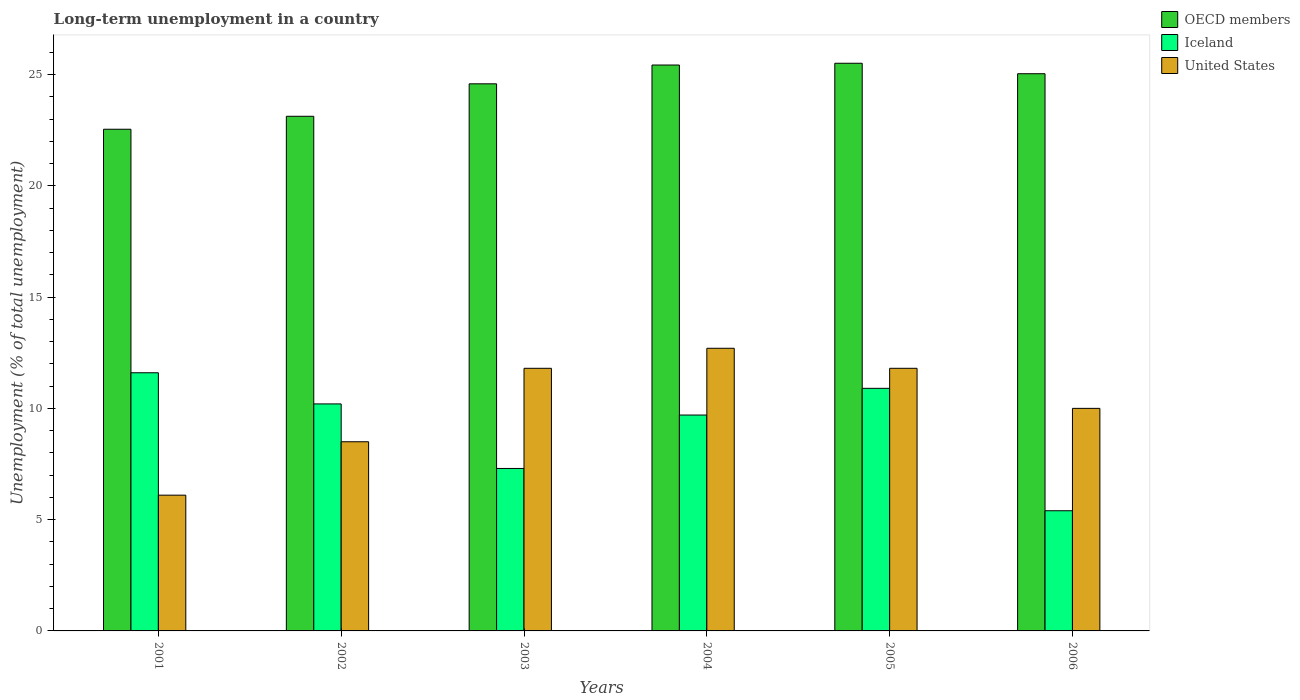Are the number of bars per tick equal to the number of legend labels?
Provide a short and direct response. Yes. Are the number of bars on each tick of the X-axis equal?
Your answer should be very brief. Yes. How many bars are there on the 6th tick from the left?
Keep it short and to the point. 3. What is the percentage of long-term unemployed population in OECD members in 2004?
Ensure brevity in your answer.  25.43. Across all years, what is the maximum percentage of long-term unemployed population in OECD members?
Your response must be concise. 25.51. Across all years, what is the minimum percentage of long-term unemployed population in OECD members?
Your answer should be very brief. 22.54. In which year was the percentage of long-term unemployed population in OECD members maximum?
Give a very brief answer. 2005. In which year was the percentage of long-term unemployed population in Iceland minimum?
Your answer should be compact. 2006. What is the total percentage of long-term unemployed population in Iceland in the graph?
Your answer should be very brief. 55.1. What is the difference between the percentage of long-term unemployed population in Iceland in 2003 and that in 2006?
Your answer should be compact. 1.9. What is the difference between the percentage of long-term unemployed population in Iceland in 2003 and the percentage of long-term unemployed population in United States in 2001?
Offer a very short reply. 1.2. What is the average percentage of long-term unemployed population in United States per year?
Offer a terse response. 10.15. In the year 2005, what is the difference between the percentage of long-term unemployed population in Iceland and percentage of long-term unemployed population in United States?
Provide a short and direct response. -0.9. In how many years, is the percentage of long-term unemployed population in OECD members greater than 6 %?
Your answer should be very brief. 6. What is the ratio of the percentage of long-term unemployed population in Iceland in 2001 to that in 2002?
Provide a short and direct response. 1.14. Is the percentage of long-term unemployed population in OECD members in 2002 less than that in 2003?
Give a very brief answer. Yes. Is the difference between the percentage of long-term unemployed population in Iceland in 2003 and 2004 greater than the difference between the percentage of long-term unemployed population in United States in 2003 and 2004?
Your answer should be very brief. No. What is the difference between the highest and the second highest percentage of long-term unemployed population in United States?
Your response must be concise. 0.9. What is the difference between the highest and the lowest percentage of long-term unemployed population in Iceland?
Your answer should be compact. 6.2. Is it the case that in every year, the sum of the percentage of long-term unemployed population in Iceland and percentage of long-term unemployed population in United States is greater than the percentage of long-term unemployed population in OECD members?
Offer a very short reply. No. How many bars are there?
Offer a very short reply. 18. Are all the bars in the graph horizontal?
Ensure brevity in your answer.  No. Are the values on the major ticks of Y-axis written in scientific E-notation?
Ensure brevity in your answer.  No. How many legend labels are there?
Provide a succinct answer. 3. How are the legend labels stacked?
Give a very brief answer. Vertical. What is the title of the graph?
Provide a short and direct response. Long-term unemployment in a country. What is the label or title of the Y-axis?
Keep it short and to the point. Unemployment (% of total unemployment). What is the Unemployment (% of total unemployment) of OECD members in 2001?
Your answer should be very brief. 22.54. What is the Unemployment (% of total unemployment) in Iceland in 2001?
Give a very brief answer. 11.6. What is the Unemployment (% of total unemployment) in United States in 2001?
Give a very brief answer. 6.1. What is the Unemployment (% of total unemployment) of OECD members in 2002?
Ensure brevity in your answer.  23.12. What is the Unemployment (% of total unemployment) of Iceland in 2002?
Your answer should be very brief. 10.2. What is the Unemployment (% of total unemployment) in OECD members in 2003?
Provide a short and direct response. 24.58. What is the Unemployment (% of total unemployment) in Iceland in 2003?
Provide a short and direct response. 7.3. What is the Unemployment (% of total unemployment) in United States in 2003?
Your response must be concise. 11.8. What is the Unemployment (% of total unemployment) of OECD members in 2004?
Make the answer very short. 25.43. What is the Unemployment (% of total unemployment) in Iceland in 2004?
Ensure brevity in your answer.  9.7. What is the Unemployment (% of total unemployment) in United States in 2004?
Provide a short and direct response. 12.7. What is the Unemployment (% of total unemployment) in OECD members in 2005?
Ensure brevity in your answer.  25.51. What is the Unemployment (% of total unemployment) in Iceland in 2005?
Your response must be concise. 10.9. What is the Unemployment (% of total unemployment) of United States in 2005?
Provide a short and direct response. 11.8. What is the Unemployment (% of total unemployment) in OECD members in 2006?
Your answer should be very brief. 25.04. What is the Unemployment (% of total unemployment) in Iceland in 2006?
Your answer should be compact. 5.4. What is the Unemployment (% of total unemployment) of United States in 2006?
Your answer should be compact. 10. Across all years, what is the maximum Unemployment (% of total unemployment) of OECD members?
Give a very brief answer. 25.51. Across all years, what is the maximum Unemployment (% of total unemployment) in Iceland?
Keep it short and to the point. 11.6. Across all years, what is the maximum Unemployment (% of total unemployment) of United States?
Make the answer very short. 12.7. Across all years, what is the minimum Unemployment (% of total unemployment) in OECD members?
Make the answer very short. 22.54. Across all years, what is the minimum Unemployment (% of total unemployment) in Iceland?
Offer a terse response. 5.4. Across all years, what is the minimum Unemployment (% of total unemployment) of United States?
Ensure brevity in your answer.  6.1. What is the total Unemployment (% of total unemployment) of OECD members in the graph?
Your answer should be very brief. 146.22. What is the total Unemployment (% of total unemployment) of Iceland in the graph?
Your answer should be compact. 55.1. What is the total Unemployment (% of total unemployment) in United States in the graph?
Your response must be concise. 60.9. What is the difference between the Unemployment (% of total unemployment) in OECD members in 2001 and that in 2002?
Keep it short and to the point. -0.58. What is the difference between the Unemployment (% of total unemployment) in United States in 2001 and that in 2002?
Give a very brief answer. -2.4. What is the difference between the Unemployment (% of total unemployment) in OECD members in 2001 and that in 2003?
Provide a succinct answer. -2.04. What is the difference between the Unemployment (% of total unemployment) of Iceland in 2001 and that in 2003?
Keep it short and to the point. 4.3. What is the difference between the Unemployment (% of total unemployment) in United States in 2001 and that in 2003?
Give a very brief answer. -5.7. What is the difference between the Unemployment (% of total unemployment) in OECD members in 2001 and that in 2004?
Your response must be concise. -2.89. What is the difference between the Unemployment (% of total unemployment) in United States in 2001 and that in 2004?
Ensure brevity in your answer.  -6.6. What is the difference between the Unemployment (% of total unemployment) in OECD members in 2001 and that in 2005?
Your answer should be very brief. -2.96. What is the difference between the Unemployment (% of total unemployment) in Iceland in 2001 and that in 2005?
Ensure brevity in your answer.  0.7. What is the difference between the Unemployment (% of total unemployment) of United States in 2001 and that in 2005?
Make the answer very short. -5.7. What is the difference between the Unemployment (% of total unemployment) of OECD members in 2001 and that in 2006?
Your answer should be compact. -2.49. What is the difference between the Unemployment (% of total unemployment) in Iceland in 2001 and that in 2006?
Provide a succinct answer. 6.2. What is the difference between the Unemployment (% of total unemployment) in United States in 2001 and that in 2006?
Provide a short and direct response. -3.9. What is the difference between the Unemployment (% of total unemployment) of OECD members in 2002 and that in 2003?
Provide a succinct answer. -1.46. What is the difference between the Unemployment (% of total unemployment) in Iceland in 2002 and that in 2003?
Ensure brevity in your answer.  2.9. What is the difference between the Unemployment (% of total unemployment) of OECD members in 2002 and that in 2004?
Offer a terse response. -2.3. What is the difference between the Unemployment (% of total unemployment) of OECD members in 2002 and that in 2005?
Keep it short and to the point. -2.38. What is the difference between the Unemployment (% of total unemployment) in OECD members in 2002 and that in 2006?
Offer a very short reply. -1.91. What is the difference between the Unemployment (% of total unemployment) in OECD members in 2003 and that in 2004?
Give a very brief answer. -0.84. What is the difference between the Unemployment (% of total unemployment) in Iceland in 2003 and that in 2004?
Your response must be concise. -2.4. What is the difference between the Unemployment (% of total unemployment) in United States in 2003 and that in 2004?
Provide a short and direct response. -0.9. What is the difference between the Unemployment (% of total unemployment) of OECD members in 2003 and that in 2005?
Give a very brief answer. -0.92. What is the difference between the Unemployment (% of total unemployment) in OECD members in 2003 and that in 2006?
Provide a short and direct response. -0.45. What is the difference between the Unemployment (% of total unemployment) of Iceland in 2003 and that in 2006?
Provide a succinct answer. 1.9. What is the difference between the Unemployment (% of total unemployment) of United States in 2003 and that in 2006?
Give a very brief answer. 1.8. What is the difference between the Unemployment (% of total unemployment) of OECD members in 2004 and that in 2005?
Provide a succinct answer. -0.08. What is the difference between the Unemployment (% of total unemployment) in United States in 2004 and that in 2005?
Offer a terse response. 0.9. What is the difference between the Unemployment (% of total unemployment) of OECD members in 2004 and that in 2006?
Provide a succinct answer. 0.39. What is the difference between the Unemployment (% of total unemployment) in OECD members in 2005 and that in 2006?
Ensure brevity in your answer.  0.47. What is the difference between the Unemployment (% of total unemployment) in OECD members in 2001 and the Unemployment (% of total unemployment) in Iceland in 2002?
Offer a terse response. 12.34. What is the difference between the Unemployment (% of total unemployment) in OECD members in 2001 and the Unemployment (% of total unemployment) in United States in 2002?
Your answer should be very brief. 14.04. What is the difference between the Unemployment (% of total unemployment) of Iceland in 2001 and the Unemployment (% of total unemployment) of United States in 2002?
Offer a terse response. 3.1. What is the difference between the Unemployment (% of total unemployment) of OECD members in 2001 and the Unemployment (% of total unemployment) of Iceland in 2003?
Your answer should be compact. 15.24. What is the difference between the Unemployment (% of total unemployment) of OECD members in 2001 and the Unemployment (% of total unemployment) of United States in 2003?
Your answer should be very brief. 10.74. What is the difference between the Unemployment (% of total unemployment) of Iceland in 2001 and the Unemployment (% of total unemployment) of United States in 2003?
Make the answer very short. -0.2. What is the difference between the Unemployment (% of total unemployment) of OECD members in 2001 and the Unemployment (% of total unemployment) of Iceland in 2004?
Give a very brief answer. 12.84. What is the difference between the Unemployment (% of total unemployment) in OECD members in 2001 and the Unemployment (% of total unemployment) in United States in 2004?
Provide a succinct answer. 9.84. What is the difference between the Unemployment (% of total unemployment) of Iceland in 2001 and the Unemployment (% of total unemployment) of United States in 2004?
Give a very brief answer. -1.1. What is the difference between the Unemployment (% of total unemployment) in OECD members in 2001 and the Unemployment (% of total unemployment) in Iceland in 2005?
Your response must be concise. 11.64. What is the difference between the Unemployment (% of total unemployment) of OECD members in 2001 and the Unemployment (% of total unemployment) of United States in 2005?
Give a very brief answer. 10.74. What is the difference between the Unemployment (% of total unemployment) in OECD members in 2001 and the Unemployment (% of total unemployment) in Iceland in 2006?
Your answer should be very brief. 17.14. What is the difference between the Unemployment (% of total unemployment) of OECD members in 2001 and the Unemployment (% of total unemployment) of United States in 2006?
Your answer should be very brief. 12.54. What is the difference between the Unemployment (% of total unemployment) in OECD members in 2002 and the Unemployment (% of total unemployment) in Iceland in 2003?
Make the answer very short. 15.82. What is the difference between the Unemployment (% of total unemployment) of OECD members in 2002 and the Unemployment (% of total unemployment) of United States in 2003?
Ensure brevity in your answer.  11.32. What is the difference between the Unemployment (% of total unemployment) of OECD members in 2002 and the Unemployment (% of total unemployment) of Iceland in 2004?
Provide a short and direct response. 13.42. What is the difference between the Unemployment (% of total unemployment) in OECD members in 2002 and the Unemployment (% of total unemployment) in United States in 2004?
Make the answer very short. 10.42. What is the difference between the Unemployment (% of total unemployment) in OECD members in 2002 and the Unemployment (% of total unemployment) in Iceland in 2005?
Offer a very short reply. 12.22. What is the difference between the Unemployment (% of total unemployment) in OECD members in 2002 and the Unemployment (% of total unemployment) in United States in 2005?
Provide a succinct answer. 11.32. What is the difference between the Unemployment (% of total unemployment) of Iceland in 2002 and the Unemployment (% of total unemployment) of United States in 2005?
Provide a succinct answer. -1.6. What is the difference between the Unemployment (% of total unemployment) in OECD members in 2002 and the Unemployment (% of total unemployment) in Iceland in 2006?
Your answer should be very brief. 17.72. What is the difference between the Unemployment (% of total unemployment) in OECD members in 2002 and the Unemployment (% of total unemployment) in United States in 2006?
Your response must be concise. 13.12. What is the difference between the Unemployment (% of total unemployment) of OECD members in 2003 and the Unemployment (% of total unemployment) of Iceland in 2004?
Provide a succinct answer. 14.88. What is the difference between the Unemployment (% of total unemployment) in OECD members in 2003 and the Unemployment (% of total unemployment) in United States in 2004?
Make the answer very short. 11.88. What is the difference between the Unemployment (% of total unemployment) of Iceland in 2003 and the Unemployment (% of total unemployment) of United States in 2004?
Provide a succinct answer. -5.4. What is the difference between the Unemployment (% of total unemployment) in OECD members in 2003 and the Unemployment (% of total unemployment) in Iceland in 2005?
Offer a very short reply. 13.68. What is the difference between the Unemployment (% of total unemployment) of OECD members in 2003 and the Unemployment (% of total unemployment) of United States in 2005?
Your answer should be compact. 12.78. What is the difference between the Unemployment (% of total unemployment) of Iceland in 2003 and the Unemployment (% of total unemployment) of United States in 2005?
Give a very brief answer. -4.5. What is the difference between the Unemployment (% of total unemployment) in OECD members in 2003 and the Unemployment (% of total unemployment) in Iceland in 2006?
Keep it short and to the point. 19.18. What is the difference between the Unemployment (% of total unemployment) in OECD members in 2003 and the Unemployment (% of total unemployment) in United States in 2006?
Provide a short and direct response. 14.58. What is the difference between the Unemployment (% of total unemployment) of Iceland in 2003 and the Unemployment (% of total unemployment) of United States in 2006?
Give a very brief answer. -2.7. What is the difference between the Unemployment (% of total unemployment) in OECD members in 2004 and the Unemployment (% of total unemployment) in Iceland in 2005?
Give a very brief answer. 14.53. What is the difference between the Unemployment (% of total unemployment) in OECD members in 2004 and the Unemployment (% of total unemployment) in United States in 2005?
Your answer should be very brief. 13.63. What is the difference between the Unemployment (% of total unemployment) in Iceland in 2004 and the Unemployment (% of total unemployment) in United States in 2005?
Your answer should be compact. -2.1. What is the difference between the Unemployment (% of total unemployment) of OECD members in 2004 and the Unemployment (% of total unemployment) of Iceland in 2006?
Your answer should be very brief. 20.03. What is the difference between the Unemployment (% of total unemployment) in OECD members in 2004 and the Unemployment (% of total unemployment) in United States in 2006?
Provide a short and direct response. 15.43. What is the difference between the Unemployment (% of total unemployment) in OECD members in 2005 and the Unemployment (% of total unemployment) in Iceland in 2006?
Offer a terse response. 20.11. What is the difference between the Unemployment (% of total unemployment) of OECD members in 2005 and the Unemployment (% of total unemployment) of United States in 2006?
Keep it short and to the point. 15.51. What is the difference between the Unemployment (% of total unemployment) in Iceland in 2005 and the Unemployment (% of total unemployment) in United States in 2006?
Make the answer very short. 0.9. What is the average Unemployment (% of total unemployment) in OECD members per year?
Keep it short and to the point. 24.37. What is the average Unemployment (% of total unemployment) in Iceland per year?
Your answer should be very brief. 9.18. What is the average Unemployment (% of total unemployment) in United States per year?
Provide a succinct answer. 10.15. In the year 2001, what is the difference between the Unemployment (% of total unemployment) of OECD members and Unemployment (% of total unemployment) of Iceland?
Provide a succinct answer. 10.94. In the year 2001, what is the difference between the Unemployment (% of total unemployment) in OECD members and Unemployment (% of total unemployment) in United States?
Provide a short and direct response. 16.44. In the year 2001, what is the difference between the Unemployment (% of total unemployment) of Iceland and Unemployment (% of total unemployment) of United States?
Offer a very short reply. 5.5. In the year 2002, what is the difference between the Unemployment (% of total unemployment) in OECD members and Unemployment (% of total unemployment) in Iceland?
Provide a succinct answer. 12.92. In the year 2002, what is the difference between the Unemployment (% of total unemployment) of OECD members and Unemployment (% of total unemployment) of United States?
Give a very brief answer. 14.62. In the year 2003, what is the difference between the Unemployment (% of total unemployment) in OECD members and Unemployment (% of total unemployment) in Iceland?
Provide a short and direct response. 17.28. In the year 2003, what is the difference between the Unemployment (% of total unemployment) in OECD members and Unemployment (% of total unemployment) in United States?
Keep it short and to the point. 12.78. In the year 2004, what is the difference between the Unemployment (% of total unemployment) in OECD members and Unemployment (% of total unemployment) in Iceland?
Offer a very short reply. 15.73. In the year 2004, what is the difference between the Unemployment (% of total unemployment) of OECD members and Unemployment (% of total unemployment) of United States?
Provide a short and direct response. 12.73. In the year 2004, what is the difference between the Unemployment (% of total unemployment) of Iceland and Unemployment (% of total unemployment) of United States?
Make the answer very short. -3. In the year 2005, what is the difference between the Unemployment (% of total unemployment) of OECD members and Unemployment (% of total unemployment) of Iceland?
Keep it short and to the point. 14.61. In the year 2005, what is the difference between the Unemployment (% of total unemployment) in OECD members and Unemployment (% of total unemployment) in United States?
Your answer should be very brief. 13.71. In the year 2005, what is the difference between the Unemployment (% of total unemployment) of Iceland and Unemployment (% of total unemployment) of United States?
Offer a terse response. -0.9. In the year 2006, what is the difference between the Unemployment (% of total unemployment) in OECD members and Unemployment (% of total unemployment) in Iceland?
Your answer should be very brief. 19.64. In the year 2006, what is the difference between the Unemployment (% of total unemployment) of OECD members and Unemployment (% of total unemployment) of United States?
Offer a terse response. 15.04. What is the ratio of the Unemployment (% of total unemployment) in OECD members in 2001 to that in 2002?
Your answer should be very brief. 0.97. What is the ratio of the Unemployment (% of total unemployment) of Iceland in 2001 to that in 2002?
Provide a short and direct response. 1.14. What is the ratio of the Unemployment (% of total unemployment) of United States in 2001 to that in 2002?
Provide a short and direct response. 0.72. What is the ratio of the Unemployment (% of total unemployment) of OECD members in 2001 to that in 2003?
Provide a short and direct response. 0.92. What is the ratio of the Unemployment (% of total unemployment) of Iceland in 2001 to that in 2003?
Provide a short and direct response. 1.59. What is the ratio of the Unemployment (% of total unemployment) in United States in 2001 to that in 2003?
Ensure brevity in your answer.  0.52. What is the ratio of the Unemployment (% of total unemployment) in OECD members in 2001 to that in 2004?
Give a very brief answer. 0.89. What is the ratio of the Unemployment (% of total unemployment) of Iceland in 2001 to that in 2004?
Give a very brief answer. 1.2. What is the ratio of the Unemployment (% of total unemployment) in United States in 2001 to that in 2004?
Provide a succinct answer. 0.48. What is the ratio of the Unemployment (% of total unemployment) in OECD members in 2001 to that in 2005?
Offer a very short reply. 0.88. What is the ratio of the Unemployment (% of total unemployment) of Iceland in 2001 to that in 2005?
Ensure brevity in your answer.  1.06. What is the ratio of the Unemployment (% of total unemployment) of United States in 2001 to that in 2005?
Ensure brevity in your answer.  0.52. What is the ratio of the Unemployment (% of total unemployment) of OECD members in 2001 to that in 2006?
Ensure brevity in your answer.  0.9. What is the ratio of the Unemployment (% of total unemployment) in Iceland in 2001 to that in 2006?
Provide a short and direct response. 2.15. What is the ratio of the Unemployment (% of total unemployment) in United States in 2001 to that in 2006?
Keep it short and to the point. 0.61. What is the ratio of the Unemployment (% of total unemployment) of OECD members in 2002 to that in 2003?
Your response must be concise. 0.94. What is the ratio of the Unemployment (% of total unemployment) in Iceland in 2002 to that in 2003?
Offer a very short reply. 1.4. What is the ratio of the Unemployment (% of total unemployment) of United States in 2002 to that in 2003?
Offer a terse response. 0.72. What is the ratio of the Unemployment (% of total unemployment) of OECD members in 2002 to that in 2004?
Make the answer very short. 0.91. What is the ratio of the Unemployment (% of total unemployment) in Iceland in 2002 to that in 2004?
Ensure brevity in your answer.  1.05. What is the ratio of the Unemployment (% of total unemployment) of United States in 2002 to that in 2004?
Offer a terse response. 0.67. What is the ratio of the Unemployment (% of total unemployment) of OECD members in 2002 to that in 2005?
Keep it short and to the point. 0.91. What is the ratio of the Unemployment (% of total unemployment) in Iceland in 2002 to that in 2005?
Provide a succinct answer. 0.94. What is the ratio of the Unemployment (% of total unemployment) in United States in 2002 to that in 2005?
Offer a very short reply. 0.72. What is the ratio of the Unemployment (% of total unemployment) in OECD members in 2002 to that in 2006?
Your answer should be very brief. 0.92. What is the ratio of the Unemployment (% of total unemployment) in Iceland in 2002 to that in 2006?
Provide a succinct answer. 1.89. What is the ratio of the Unemployment (% of total unemployment) in OECD members in 2003 to that in 2004?
Provide a short and direct response. 0.97. What is the ratio of the Unemployment (% of total unemployment) in Iceland in 2003 to that in 2004?
Your answer should be compact. 0.75. What is the ratio of the Unemployment (% of total unemployment) in United States in 2003 to that in 2004?
Give a very brief answer. 0.93. What is the ratio of the Unemployment (% of total unemployment) of OECD members in 2003 to that in 2005?
Give a very brief answer. 0.96. What is the ratio of the Unemployment (% of total unemployment) in Iceland in 2003 to that in 2005?
Offer a very short reply. 0.67. What is the ratio of the Unemployment (% of total unemployment) of OECD members in 2003 to that in 2006?
Make the answer very short. 0.98. What is the ratio of the Unemployment (% of total unemployment) of Iceland in 2003 to that in 2006?
Make the answer very short. 1.35. What is the ratio of the Unemployment (% of total unemployment) in United States in 2003 to that in 2006?
Provide a succinct answer. 1.18. What is the ratio of the Unemployment (% of total unemployment) in OECD members in 2004 to that in 2005?
Offer a very short reply. 1. What is the ratio of the Unemployment (% of total unemployment) of Iceland in 2004 to that in 2005?
Your answer should be compact. 0.89. What is the ratio of the Unemployment (% of total unemployment) of United States in 2004 to that in 2005?
Provide a succinct answer. 1.08. What is the ratio of the Unemployment (% of total unemployment) in OECD members in 2004 to that in 2006?
Provide a succinct answer. 1.02. What is the ratio of the Unemployment (% of total unemployment) of Iceland in 2004 to that in 2006?
Make the answer very short. 1.8. What is the ratio of the Unemployment (% of total unemployment) in United States in 2004 to that in 2006?
Make the answer very short. 1.27. What is the ratio of the Unemployment (% of total unemployment) in OECD members in 2005 to that in 2006?
Provide a succinct answer. 1.02. What is the ratio of the Unemployment (% of total unemployment) in Iceland in 2005 to that in 2006?
Offer a terse response. 2.02. What is the ratio of the Unemployment (% of total unemployment) in United States in 2005 to that in 2006?
Ensure brevity in your answer.  1.18. What is the difference between the highest and the second highest Unemployment (% of total unemployment) of OECD members?
Ensure brevity in your answer.  0.08. What is the difference between the highest and the second highest Unemployment (% of total unemployment) in Iceland?
Your response must be concise. 0.7. What is the difference between the highest and the lowest Unemployment (% of total unemployment) of OECD members?
Your answer should be very brief. 2.96. What is the difference between the highest and the lowest Unemployment (% of total unemployment) in Iceland?
Offer a very short reply. 6.2. 